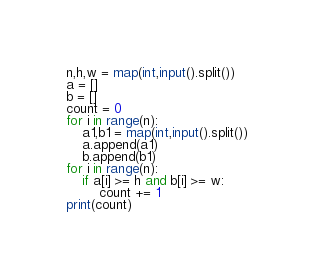<code> <loc_0><loc_0><loc_500><loc_500><_Python_>n,h,w = map(int,input().split())
a = []
b = []
count = 0
for i in range(n):
    a1,b1 = map(int,input().split())
    a.append(a1)
    b.append(b1)
for i in range(n):
    if a[i] >= h and b[i] >= w:
        count += 1
print(count)</code> 